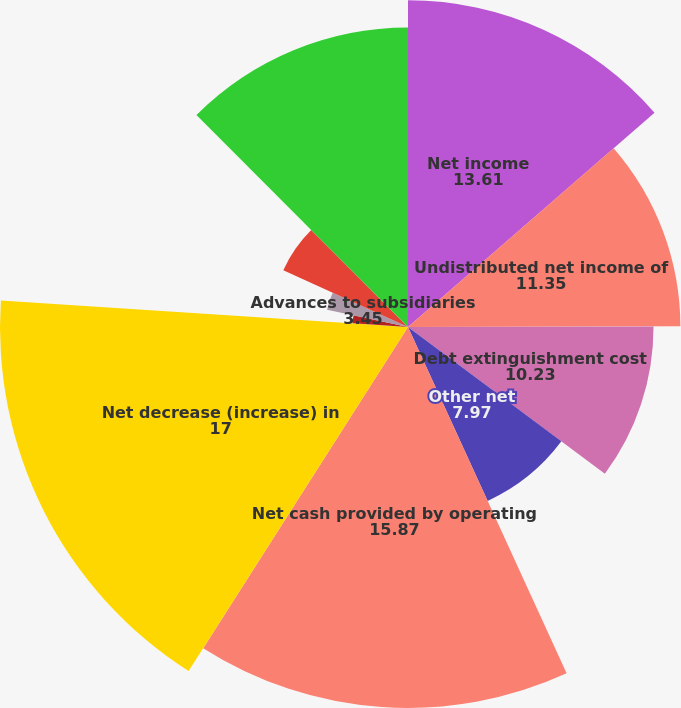<chart> <loc_0><loc_0><loc_500><loc_500><pie_chart><fcel>Net income<fcel>Undistributed net income of<fcel>Debt extinguishment cost<fcel>Other net<fcel>Net cash provided by operating<fcel>Net decrease (increase) in<fcel>Collection of advances to<fcel>Advances to subsidiaries<fcel>Proceeds from sales and<fcel>Decrease of investment in<nl><fcel>13.61%<fcel>11.35%<fcel>10.23%<fcel>7.97%<fcel>15.87%<fcel>17.0%<fcel>2.32%<fcel>3.45%<fcel>5.71%<fcel>12.48%<nl></chart> 